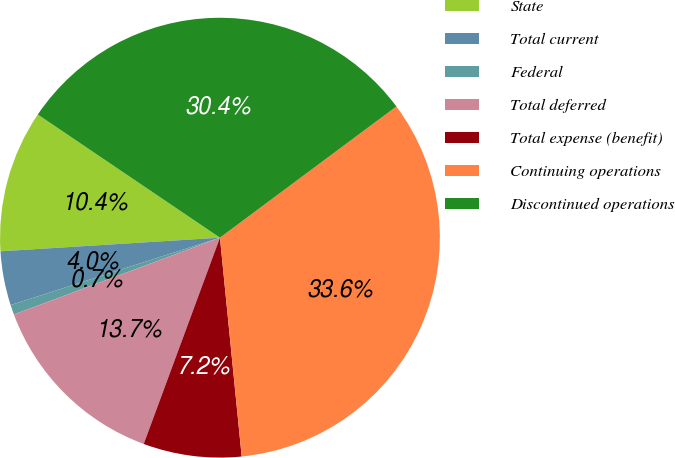Convert chart to OTSL. <chart><loc_0><loc_0><loc_500><loc_500><pie_chart><fcel>State<fcel>Total current<fcel>Federal<fcel>Total deferred<fcel>Total expense (benefit)<fcel>Continuing operations<fcel>Discontinued operations<nl><fcel>10.45%<fcel>3.97%<fcel>0.72%<fcel>13.69%<fcel>7.21%<fcel>33.6%<fcel>30.36%<nl></chart> 